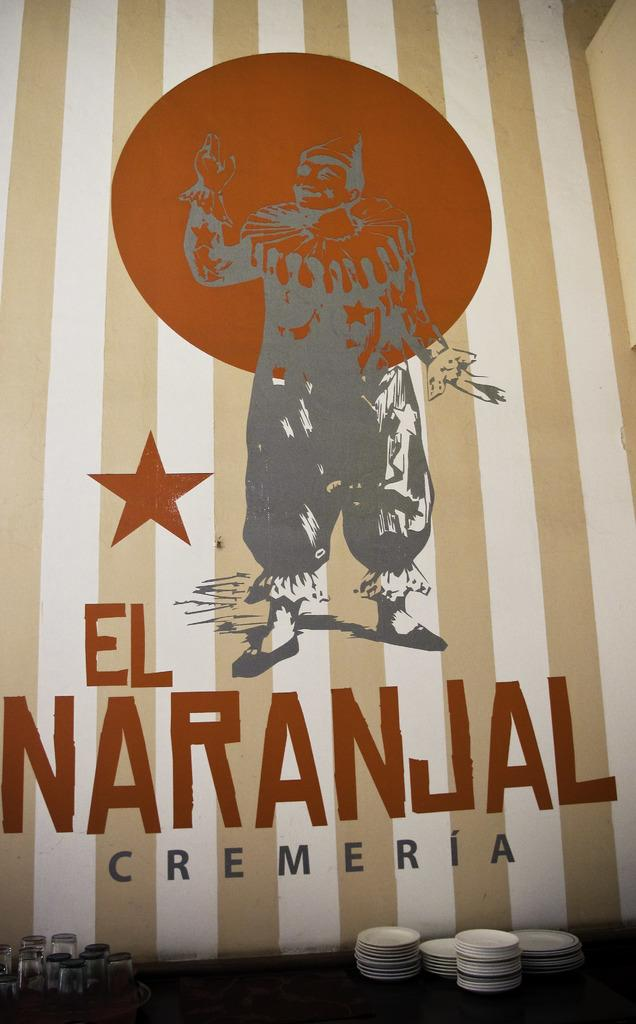What objects are in the foreground of the image? There are glasses and platters in the foreground of the image. Can you describe the paint on the wall in the background of the image? The paint on the wall in the background of the image is visible. What is the primary focus of the image? The primary focus of the image is the glasses and platters in the foreground. What type of straw is the sister holding in the image? There is no sister or straw present in the image. 